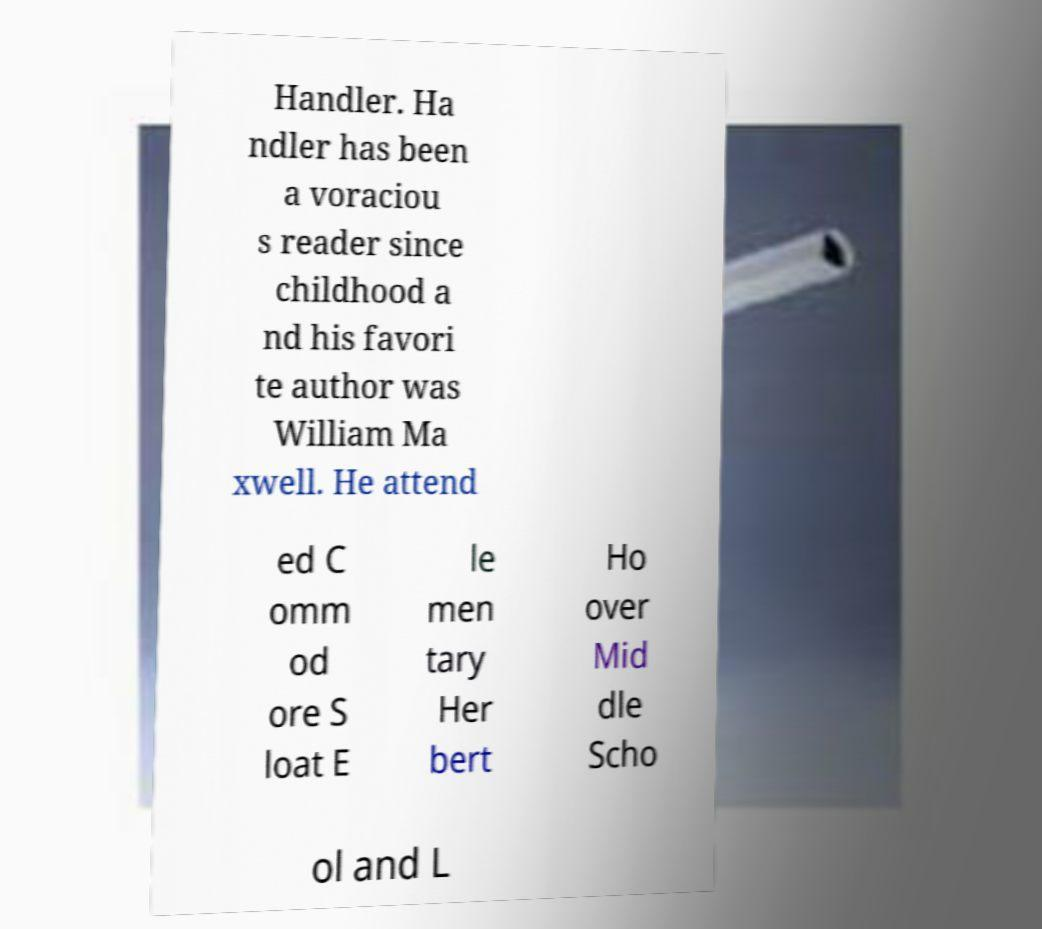For documentation purposes, I need the text within this image transcribed. Could you provide that? Handler. Ha ndler has been a voraciou s reader since childhood a nd his favori te author was William Ma xwell. He attend ed C omm od ore S loat E le men tary Her bert Ho over Mid dle Scho ol and L 